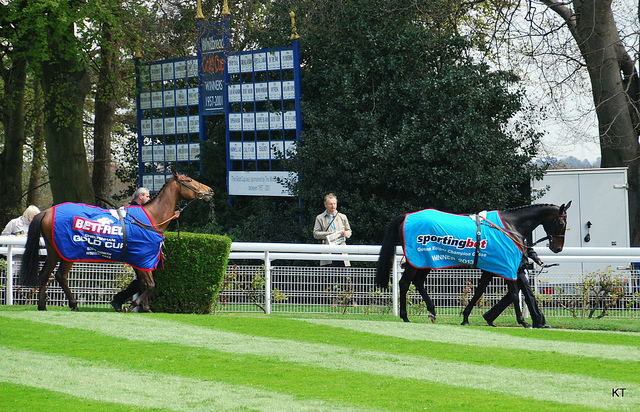Identify the text displayed in this image. BETFREL 